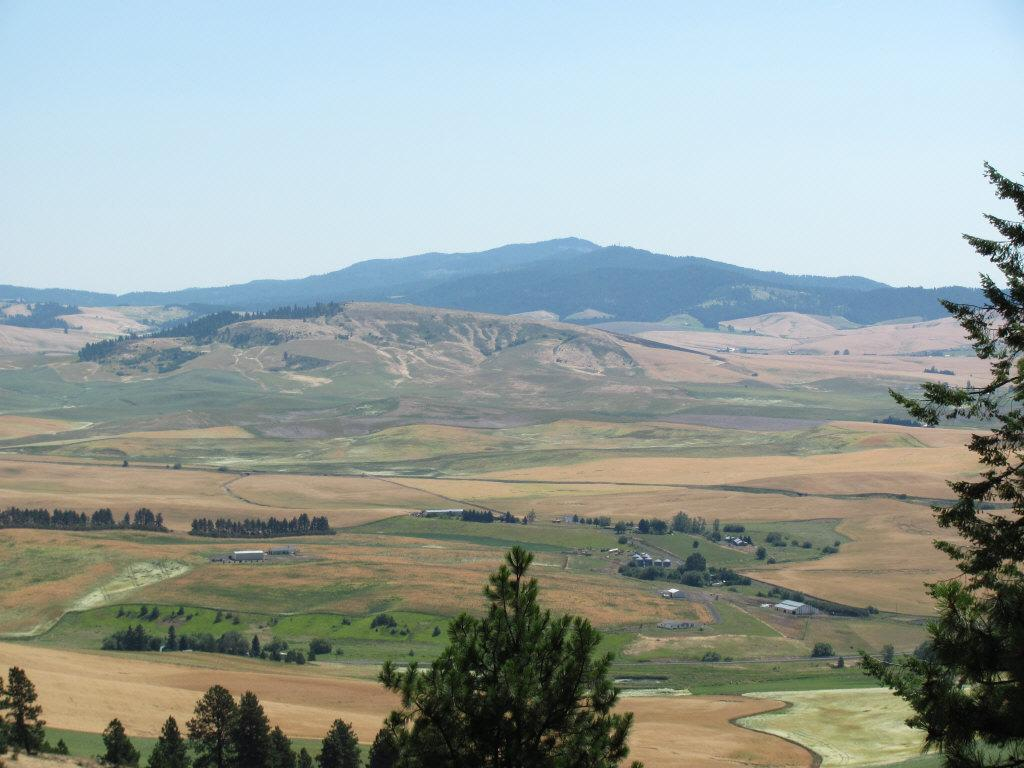What type of vegetation is present at the bottom of the image? There are trees at the bottom of the image. What type of structures are present at the bottom of the image? There are houses at the bottom of the image. What type of terrain is present at the bottom of the image? There is sand at the bottom of the image. What type of geographical feature is visible in the background of the image? There are mountains in the background of the image. What is visible at the top of the image? The sky is visible at the top of the image. What type of attraction can be seen in the image? There is no specific attraction mentioned or visible in the image. What tool is used to rake the sand in the image? There is no tool or person raking the sand in the image. 